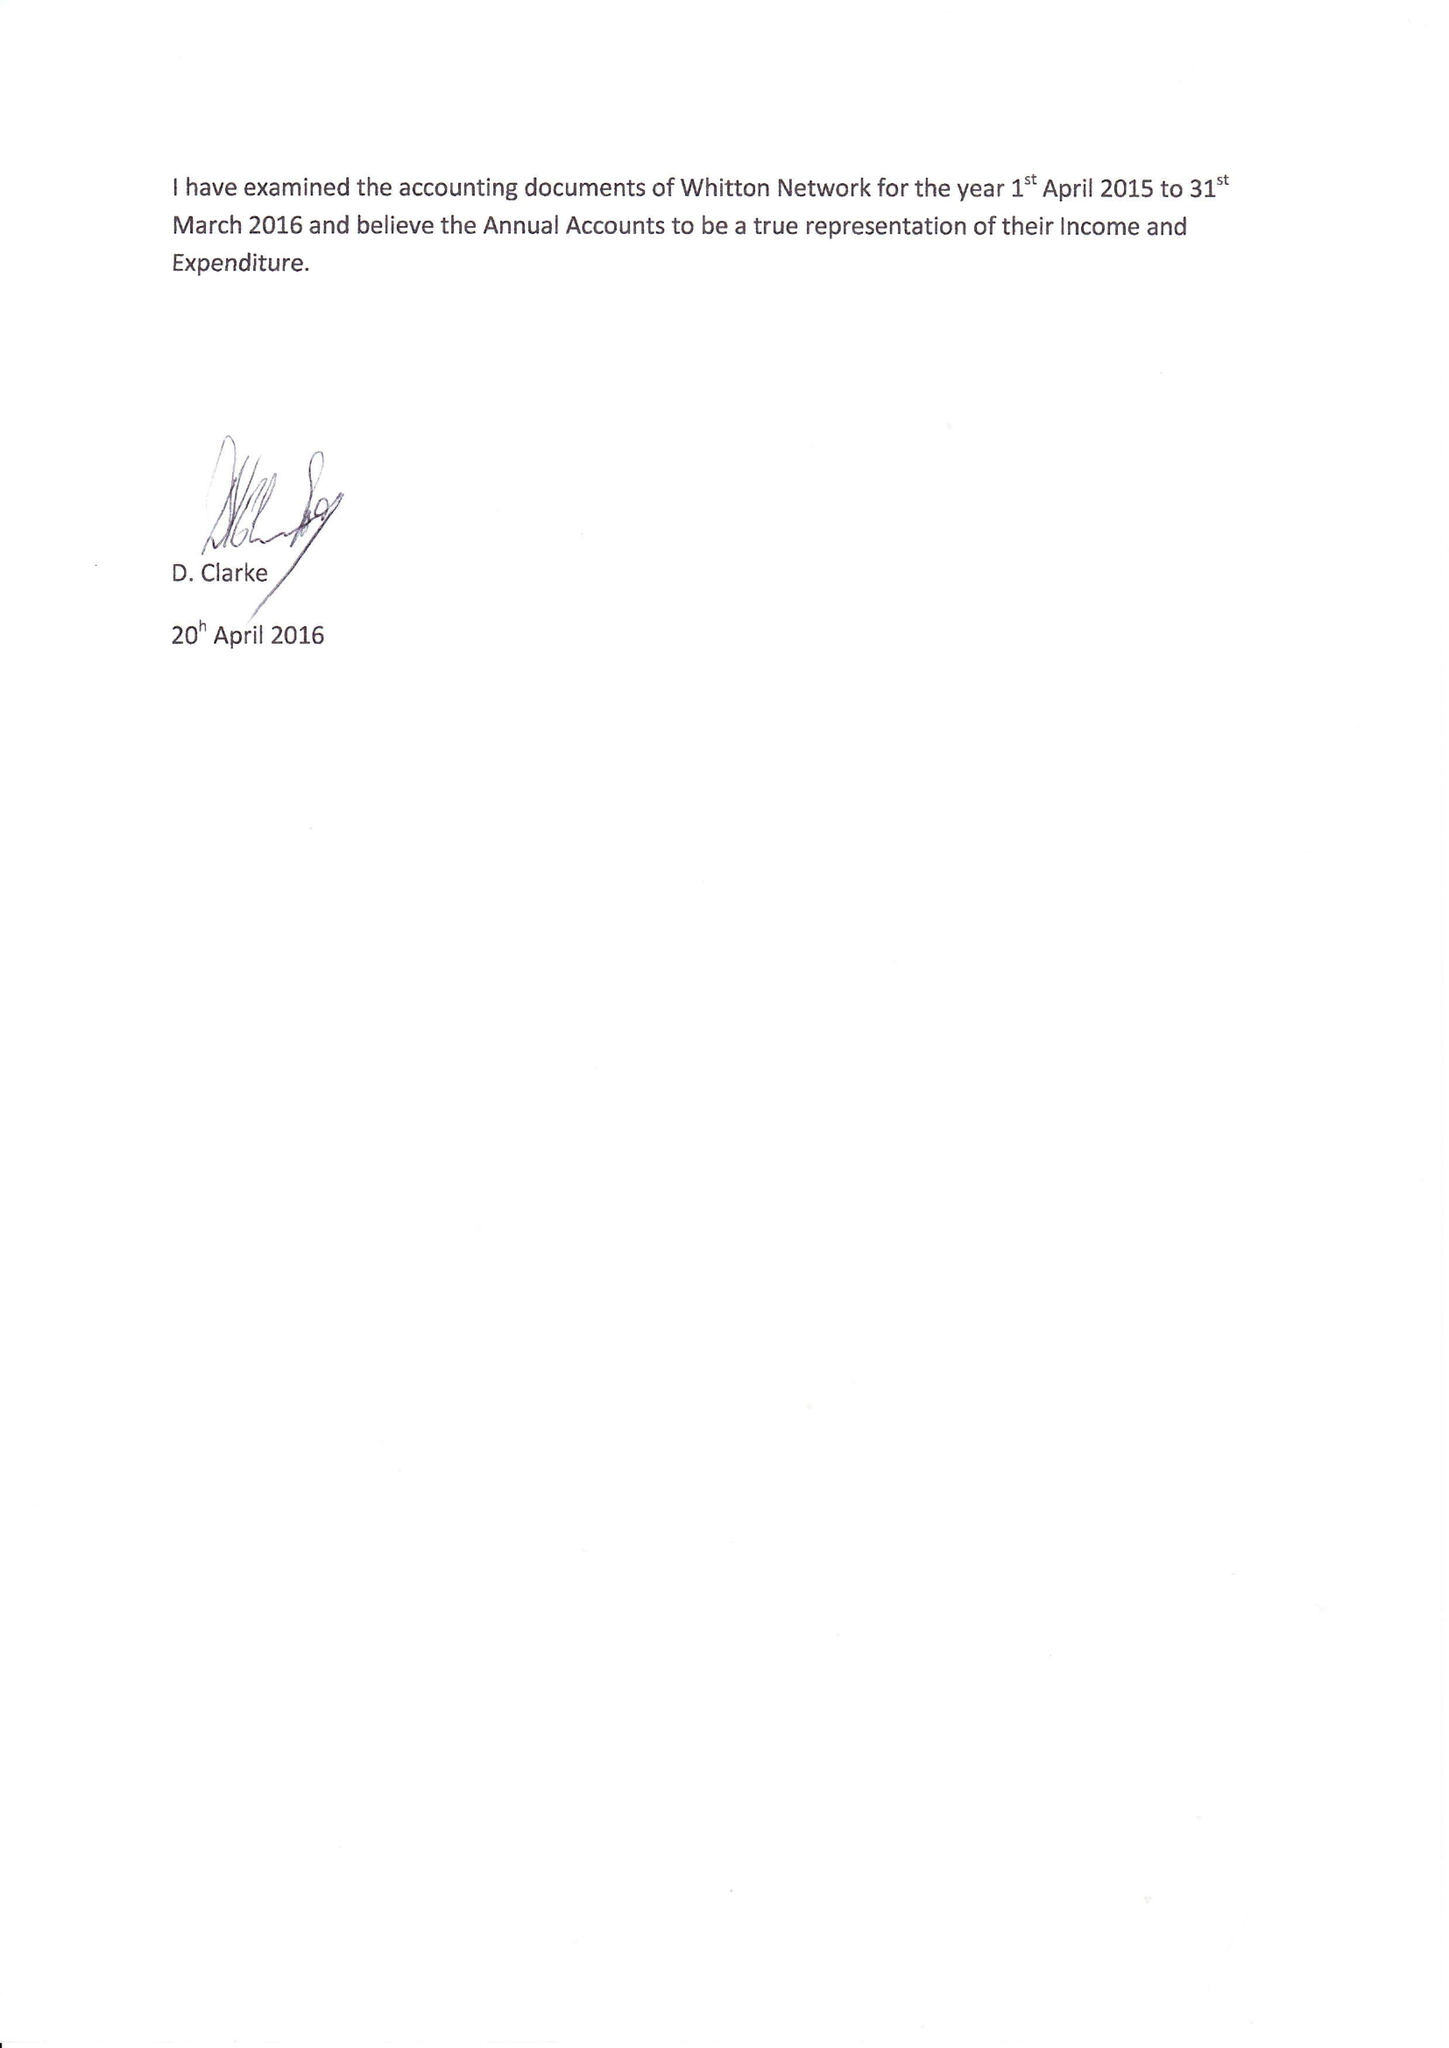What is the value for the address__post_town?
Answer the question using a single word or phrase. TWICKENHAM 